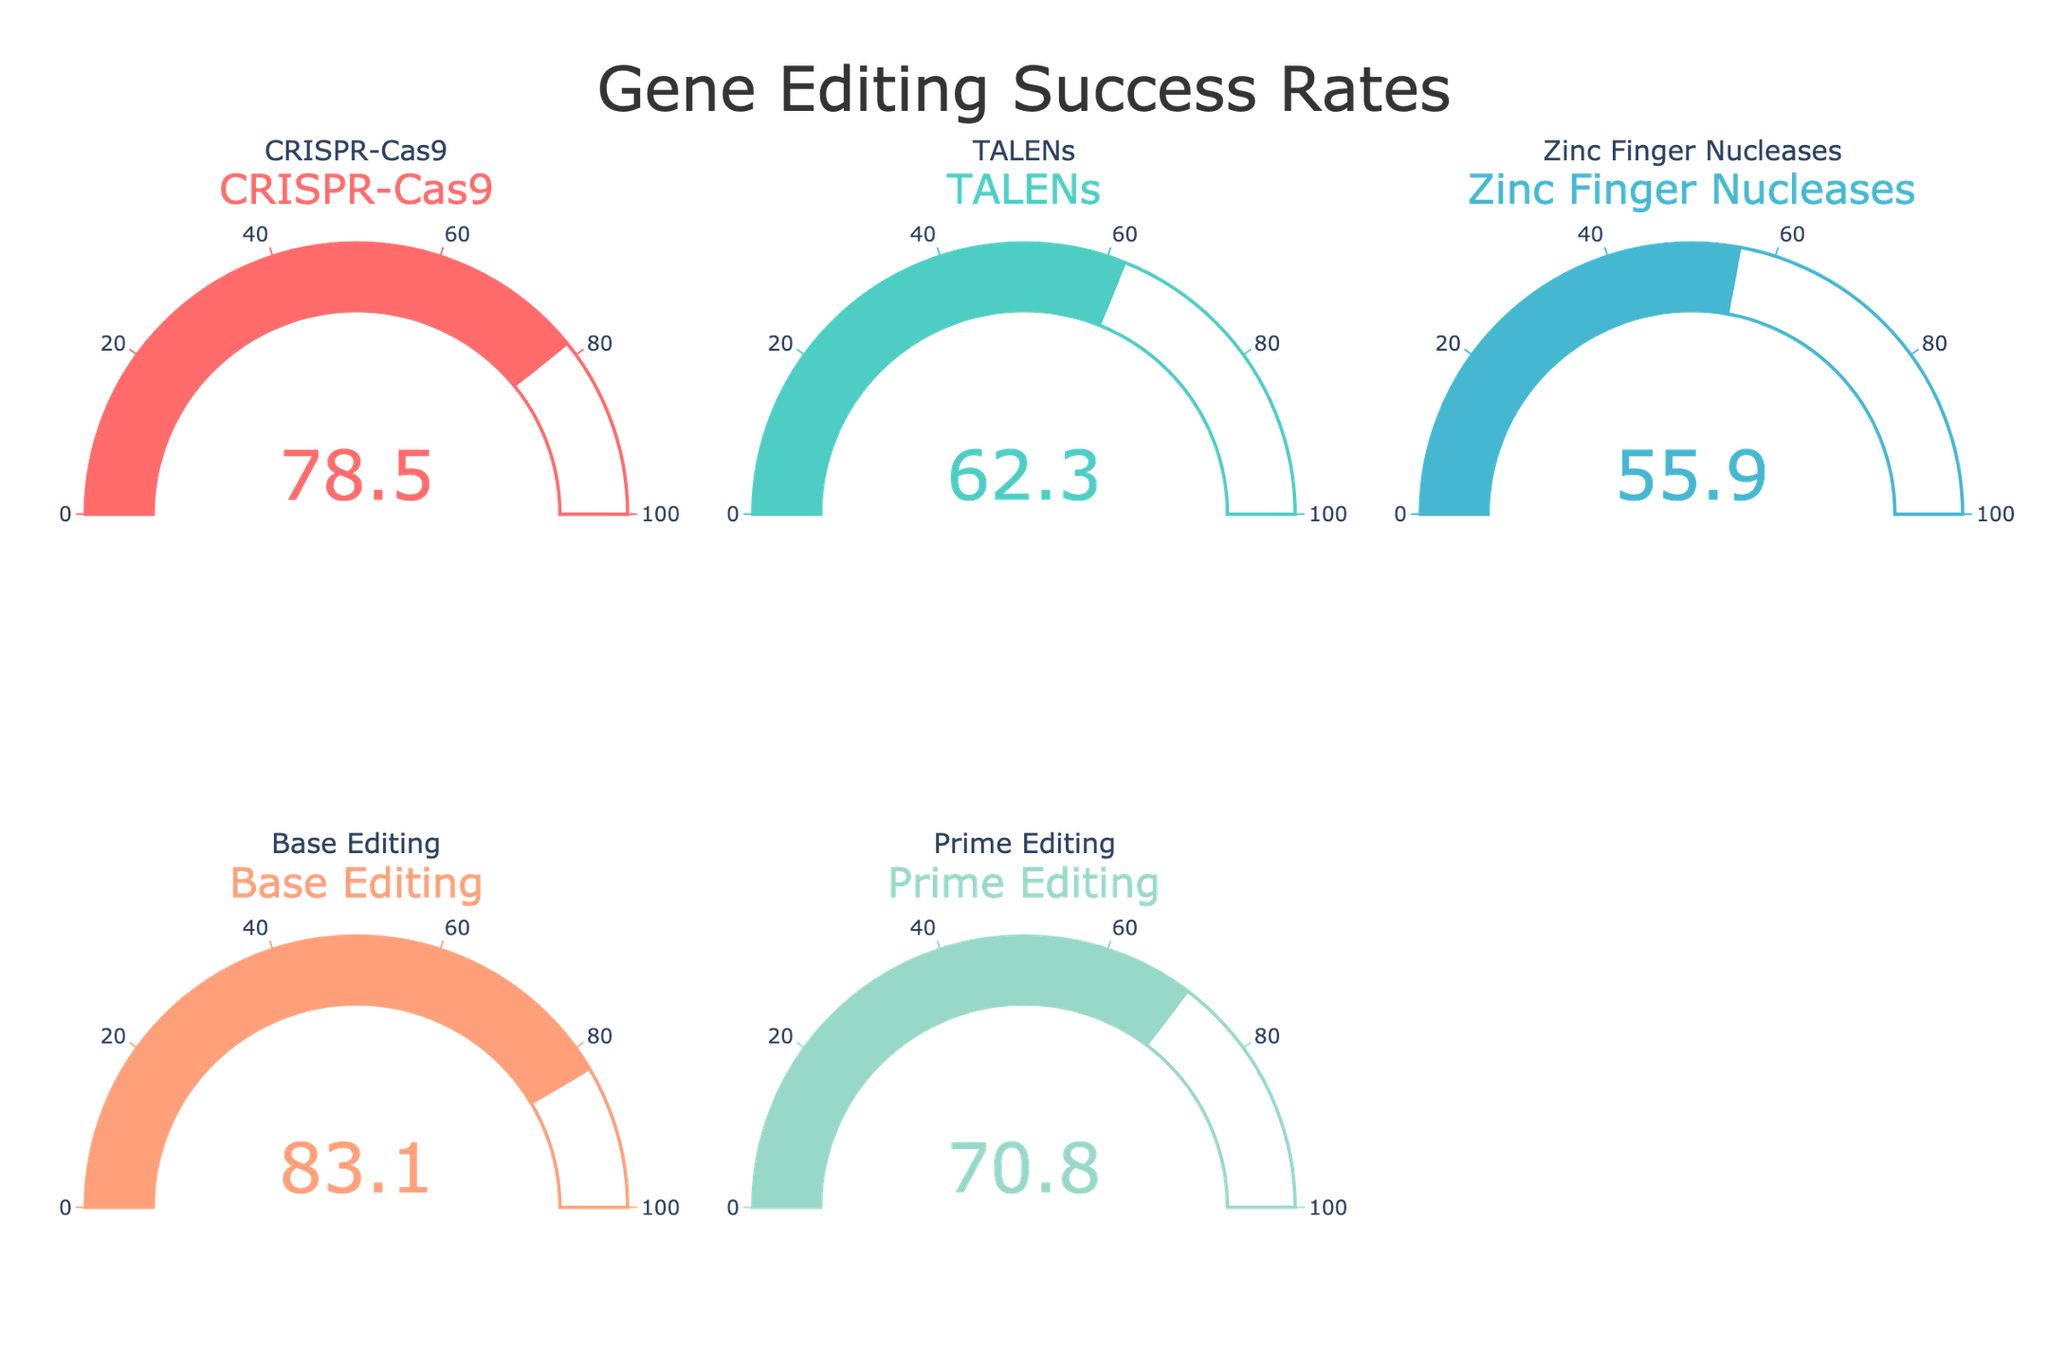Which gene editing technique has the highest success rate? The figure shows the success rates of various gene editing techniques on the gauges. By comparing the values displayed, Base Editing has the highest success rate at 83.1%.
Answer: Base Editing What is the success rate of TALENs? The figure displays the success rate for each technique on individual gauges. The gauge for TALENs shows a value of 62.3%.
Answer: 62.3% How much higher is the success rate of CRISPR-Cas9 compared to Zinc Finger Nucleases? The success rate of CRISPR-Cas9 is 78.5%, while Zinc Finger Nucleases is 55.9%. Subtract the latter from the former: 78.5% - 55.9% = 22.6%.
Answer: 22.6% What is the average success rate of all the gene editing techniques? Sum all the success rates: 78.5% + 62.3% + 55.9% + 83.1% + 70.8% = 350.6%. Divide by the number of techniques: 350.6% / 5 = 70.12%.
Answer: 70.12% Which technique has the lowest success rate? The gauge with the smallest value represents the lowest success rate. Zinc Finger Nucleases is shown to have the lowest success rate at 55.9%.
Answer: Zinc Finger Nucleases What is the combined success rate of CRISPR-Cas9 and Prime Editing? Add the success rates of CRISPR-Cas9 and Prime Editing: 78.5% + 70.8% = 149.3%.
Answer: 149.3% Are all the success rates above 50%? Check each success rate on the gauges: 78.5%, 62.3%, 55.9%, 83.1%, and 70.8%. All values are above 50%.
Answer: Yes Which technique has a success rate closest to 60%? Compare the success rates to 60%. TALENs has a success rate of 62.3%, which is the closest.
Answer: TALENs 